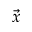Convert formula to latex. <formula><loc_0><loc_0><loc_500><loc_500>\vec { x }</formula> 